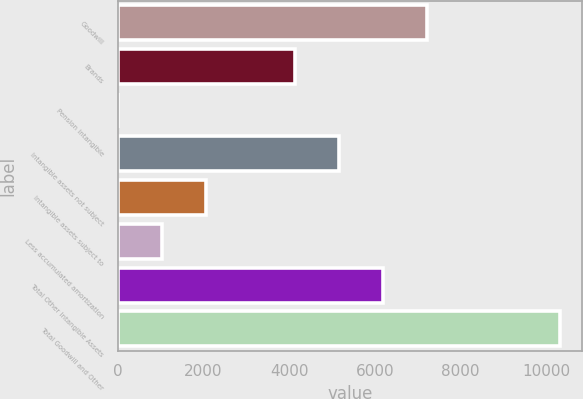Convert chart to OTSL. <chart><loc_0><loc_0><loc_500><loc_500><bar_chart><fcel>Goodwill<fcel>Brands<fcel>Pension intangible<fcel>Intangible assets not subject<fcel>Intangible assets subject to<fcel>Less accumulated amortization<fcel>Total Other Intangible Assets<fcel>Total Goodwill and Other<nl><fcel>7224.9<fcel>4129.8<fcel>3<fcel>5161.5<fcel>2066.4<fcel>1034.7<fcel>6193.2<fcel>10320<nl></chart> 